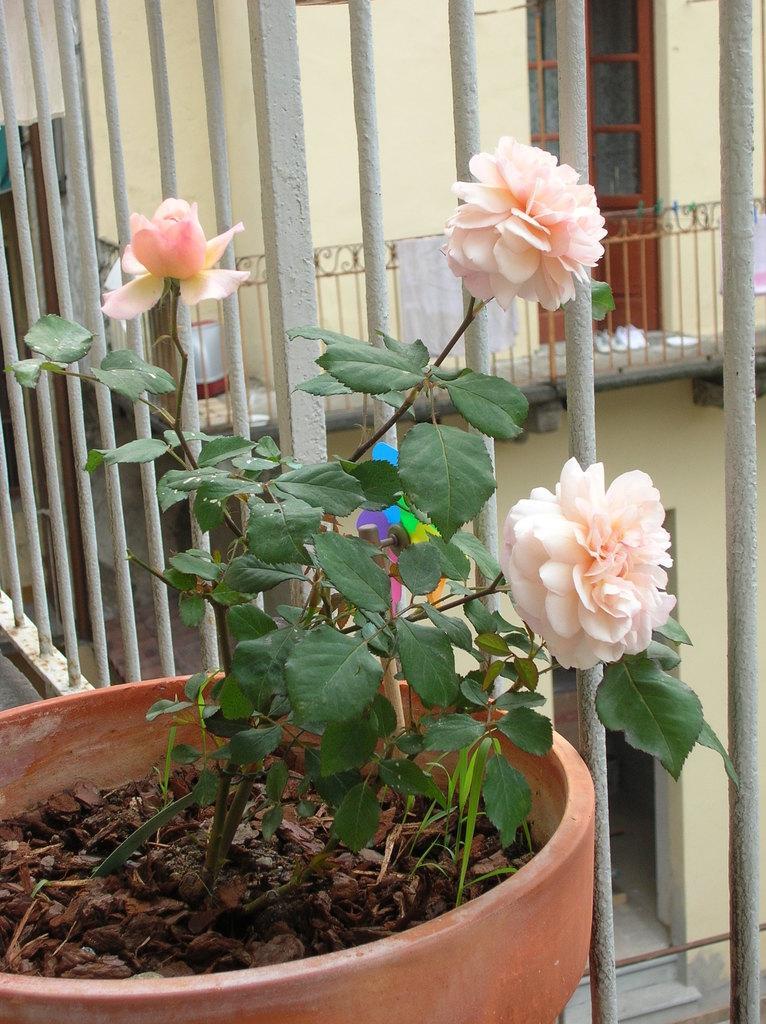Describe this image in one or two sentences. In this picture we can see a flower pot and behind the flower pot there are iron grills and a wall with a door. 